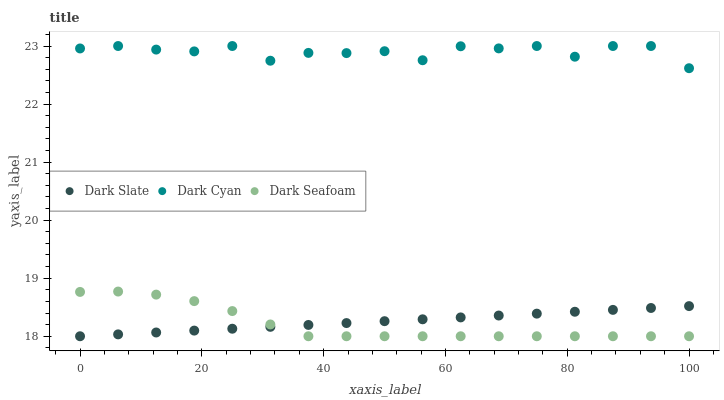Does Dark Seafoam have the minimum area under the curve?
Answer yes or no. Yes. Does Dark Cyan have the maximum area under the curve?
Answer yes or no. Yes. Does Dark Slate have the minimum area under the curve?
Answer yes or no. No. Does Dark Slate have the maximum area under the curve?
Answer yes or no. No. Is Dark Slate the smoothest?
Answer yes or no. Yes. Is Dark Cyan the roughest?
Answer yes or no. Yes. Is Dark Seafoam the smoothest?
Answer yes or no. No. Is Dark Seafoam the roughest?
Answer yes or no. No. Does Dark Slate have the lowest value?
Answer yes or no. Yes. Does Dark Cyan have the highest value?
Answer yes or no. Yes. Does Dark Seafoam have the highest value?
Answer yes or no. No. Is Dark Seafoam less than Dark Cyan?
Answer yes or no. Yes. Is Dark Cyan greater than Dark Seafoam?
Answer yes or no. Yes. Does Dark Slate intersect Dark Seafoam?
Answer yes or no. Yes. Is Dark Slate less than Dark Seafoam?
Answer yes or no. No. Is Dark Slate greater than Dark Seafoam?
Answer yes or no. No. Does Dark Seafoam intersect Dark Cyan?
Answer yes or no. No. 